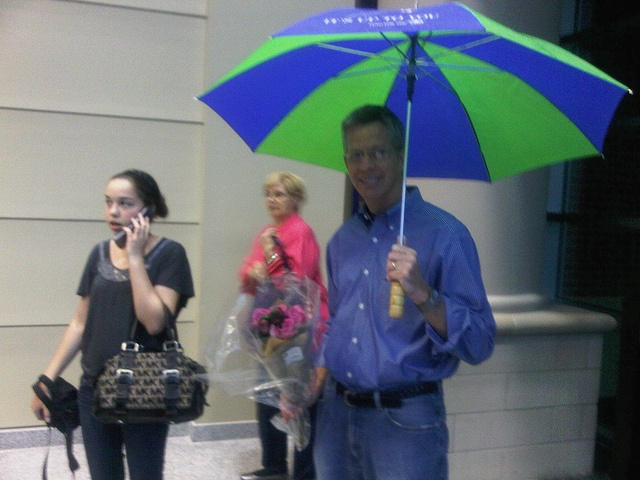Describe the objects in this image and their specific colors. I can see umbrella in darkgray, darkblue, green, and blue tones, people in darkgray, navy, black, blue, and darkblue tones, people in darkgray, black, and gray tones, people in darkgray, gray, black, and brown tones, and handbag in darkgray, black, gray, and purple tones in this image. 